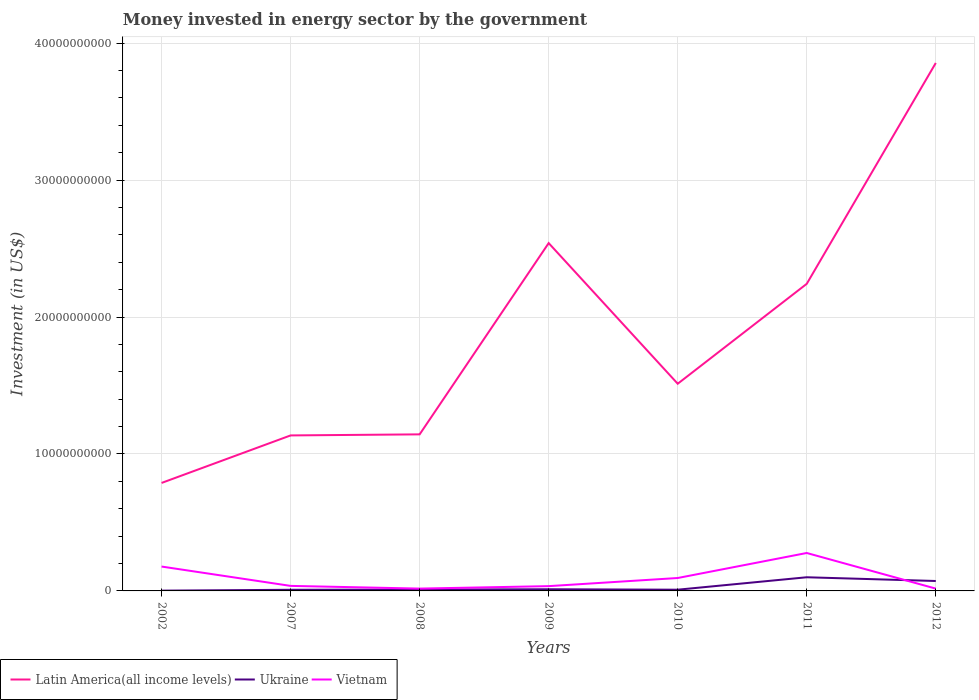How many different coloured lines are there?
Ensure brevity in your answer.  3. Is the number of lines equal to the number of legend labels?
Offer a very short reply. Yes. Across all years, what is the maximum money spent in energy sector in Latin America(all income levels)?
Your answer should be compact. 7.89e+09. In which year was the money spent in energy sector in Latin America(all income levels) maximum?
Your answer should be compact. 2002. What is the total money spent in energy sector in Vietnam in the graph?
Keep it short and to the point. -2.60e+09. What is the difference between the highest and the second highest money spent in energy sector in Ukraine?
Offer a terse response. 9.78e+08. What is the difference between the highest and the lowest money spent in energy sector in Latin America(all income levels)?
Keep it short and to the point. 3. Is the money spent in energy sector in Ukraine strictly greater than the money spent in energy sector in Vietnam over the years?
Make the answer very short. No. How many lines are there?
Provide a succinct answer. 3. Are the values on the major ticks of Y-axis written in scientific E-notation?
Ensure brevity in your answer.  No. Does the graph contain any zero values?
Provide a short and direct response. No. Where does the legend appear in the graph?
Your answer should be compact. Bottom left. How are the legend labels stacked?
Your response must be concise. Horizontal. What is the title of the graph?
Your response must be concise. Money invested in energy sector by the government. What is the label or title of the X-axis?
Provide a short and direct response. Years. What is the label or title of the Y-axis?
Your answer should be compact. Investment (in US$). What is the Investment (in US$) of Latin America(all income levels) in 2002?
Ensure brevity in your answer.  7.89e+09. What is the Investment (in US$) in Ukraine in 2002?
Provide a succinct answer. 2.00e+07. What is the Investment (in US$) of Vietnam in 2002?
Make the answer very short. 1.78e+09. What is the Investment (in US$) of Latin America(all income levels) in 2007?
Keep it short and to the point. 1.14e+1. What is the Investment (in US$) of Ukraine in 2007?
Make the answer very short. 8.34e+07. What is the Investment (in US$) of Vietnam in 2007?
Give a very brief answer. 3.67e+08. What is the Investment (in US$) of Latin America(all income levels) in 2008?
Your answer should be very brief. 1.14e+1. What is the Investment (in US$) of Ukraine in 2008?
Offer a very short reply. 1.00e+08. What is the Investment (in US$) in Vietnam in 2008?
Make the answer very short. 1.70e+08. What is the Investment (in US$) of Latin America(all income levels) in 2009?
Keep it short and to the point. 2.54e+1. What is the Investment (in US$) of Ukraine in 2009?
Provide a short and direct response. 1.21e+08. What is the Investment (in US$) of Vietnam in 2009?
Provide a succinct answer. 3.49e+08. What is the Investment (in US$) in Latin America(all income levels) in 2010?
Keep it short and to the point. 1.51e+1. What is the Investment (in US$) of Ukraine in 2010?
Offer a terse response. 8.89e+07. What is the Investment (in US$) of Vietnam in 2010?
Offer a very short reply. 9.43e+08. What is the Investment (in US$) of Latin America(all income levels) in 2011?
Offer a terse response. 2.24e+1. What is the Investment (in US$) of Ukraine in 2011?
Your response must be concise. 9.98e+08. What is the Investment (in US$) of Vietnam in 2011?
Your answer should be compact. 2.77e+09. What is the Investment (in US$) in Latin America(all income levels) in 2012?
Make the answer very short. 3.86e+1. What is the Investment (in US$) in Ukraine in 2012?
Give a very brief answer. 7.24e+08. What is the Investment (in US$) in Vietnam in 2012?
Make the answer very short. 1.69e+08. Across all years, what is the maximum Investment (in US$) of Latin America(all income levels)?
Make the answer very short. 3.86e+1. Across all years, what is the maximum Investment (in US$) in Ukraine?
Give a very brief answer. 9.98e+08. Across all years, what is the maximum Investment (in US$) of Vietnam?
Offer a terse response. 2.77e+09. Across all years, what is the minimum Investment (in US$) in Latin America(all income levels)?
Make the answer very short. 7.89e+09. Across all years, what is the minimum Investment (in US$) in Vietnam?
Your answer should be very brief. 1.69e+08. What is the total Investment (in US$) of Latin America(all income levels) in the graph?
Make the answer very short. 1.32e+11. What is the total Investment (in US$) in Ukraine in the graph?
Provide a short and direct response. 2.14e+09. What is the total Investment (in US$) of Vietnam in the graph?
Offer a terse response. 6.55e+09. What is the difference between the Investment (in US$) of Latin America(all income levels) in 2002 and that in 2007?
Offer a terse response. -3.47e+09. What is the difference between the Investment (in US$) in Ukraine in 2002 and that in 2007?
Provide a short and direct response. -6.34e+07. What is the difference between the Investment (in US$) of Vietnam in 2002 and that in 2007?
Offer a terse response. 1.41e+09. What is the difference between the Investment (in US$) of Latin America(all income levels) in 2002 and that in 2008?
Offer a terse response. -3.55e+09. What is the difference between the Investment (in US$) of Ukraine in 2002 and that in 2008?
Give a very brief answer. -8.01e+07. What is the difference between the Investment (in US$) in Vietnam in 2002 and that in 2008?
Your answer should be very brief. 1.61e+09. What is the difference between the Investment (in US$) of Latin America(all income levels) in 2002 and that in 2009?
Offer a very short reply. -1.75e+1. What is the difference between the Investment (in US$) in Ukraine in 2002 and that in 2009?
Provide a short and direct response. -1.01e+08. What is the difference between the Investment (in US$) in Vietnam in 2002 and that in 2009?
Ensure brevity in your answer.  1.43e+09. What is the difference between the Investment (in US$) of Latin America(all income levels) in 2002 and that in 2010?
Provide a short and direct response. -7.24e+09. What is the difference between the Investment (in US$) in Ukraine in 2002 and that in 2010?
Provide a succinct answer. -6.89e+07. What is the difference between the Investment (in US$) in Vietnam in 2002 and that in 2010?
Your answer should be very brief. 8.37e+08. What is the difference between the Investment (in US$) in Latin America(all income levels) in 2002 and that in 2011?
Provide a short and direct response. -1.45e+1. What is the difference between the Investment (in US$) of Ukraine in 2002 and that in 2011?
Keep it short and to the point. -9.78e+08. What is the difference between the Investment (in US$) in Vietnam in 2002 and that in 2011?
Provide a succinct answer. -9.90e+08. What is the difference between the Investment (in US$) in Latin America(all income levels) in 2002 and that in 2012?
Your response must be concise. -3.07e+1. What is the difference between the Investment (in US$) of Ukraine in 2002 and that in 2012?
Your answer should be compact. -7.04e+08. What is the difference between the Investment (in US$) of Vietnam in 2002 and that in 2012?
Offer a terse response. 1.61e+09. What is the difference between the Investment (in US$) in Latin America(all income levels) in 2007 and that in 2008?
Your answer should be compact. -7.74e+07. What is the difference between the Investment (in US$) of Ukraine in 2007 and that in 2008?
Provide a succinct answer. -1.67e+07. What is the difference between the Investment (in US$) in Vietnam in 2007 and that in 2008?
Your answer should be compact. 1.97e+08. What is the difference between the Investment (in US$) of Latin America(all income levels) in 2007 and that in 2009?
Your answer should be very brief. -1.40e+1. What is the difference between the Investment (in US$) of Ukraine in 2007 and that in 2009?
Make the answer very short. -3.73e+07. What is the difference between the Investment (in US$) in Vietnam in 2007 and that in 2009?
Offer a very short reply. 1.81e+07. What is the difference between the Investment (in US$) of Latin America(all income levels) in 2007 and that in 2010?
Give a very brief answer. -3.77e+09. What is the difference between the Investment (in US$) of Ukraine in 2007 and that in 2010?
Provide a succinct answer. -5.51e+06. What is the difference between the Investment (in US$) in Vietnam in 2007 and that in 2010?
Offer a very short reply. -5.76e+08. What is the difference between the Investment (in US$) in Latin America(all income levels) in 2007 and that in 2011?
Provide a short and direct response. -1.11e+1. What is the difference between the Investment (in US$) in Ukraine in 2007 and that in 2011?
Offer a terse response. -9.14e+08. What is the difference between the Investment (in US$) of Vietnam in 2007 and that in 2011?
Your response must be concise. -2.40e+09. What is the difference between the Investment (in US$) in Latin America(all income levels) in 2007 and that in 2012?
Provide a succinct answer. -2.72e+1. What is the difference between the Investment (in US$) in Ukraine in 2007 and that in 2012?
Provide a succinct answer. -6.41e+08. What is the difference between the Investment (in US$) of Vietnam in 2007 and that in 2012?
Keep it short and to the point. 1.99e+08. What is the difference between the Investment (in US$) in Latin America(all income levels) in 2008 and that in 2009?
Offer a very short reply. -1.40e+1. What is the difference between the Investment (in US$) of Ukraine in 2008 and that in 2009?
Ensure brevity in your answer.  -2.06e+07. What is the difference between the Investment (in US$) of Vietnam in 2008 and that in 2009?
Keep it short and to the point. -1.79e+08. What is the difference between the Investment (in US$) of Latin America(all income levels) in 2008 and that in 2010?
Provide a succinct answer. -3.70e+09. What is the difference between the Investment (in US$) of Ukraine in 2008 and that in 2010?
Ensure brevity in your answer.  1.12e+07. What is the difference between the Investment (in US$) of Vietnam in 2008 and that in 2010?
Make the answer very short. -7.73e+08. What is the difference between the Investment (in US$) in Latin America(all income levels) in 2008 and that in 2011?
Provide a short and direct response. -1.10e+1. What is the difference between the Investment (in US$) in Ukraine in 2008 and that in 2011?
Your answer should be compact. -8.98e+08. What is the difference between the Investment (in US$) of Vietnam in 2008 and that in 2011?
Your answer should be compact. -2.60e+09. What is the difference between the Investment (in US$) of Latin America(all income levels) in 2008 and that in 2012?
Your response must be concise. -2.71e+1. What is the difference between the Investment (in US$) in Ukraine in 2008 and that in 2012?
Your answer should be very brief. -6.24e+08. What is the difference between the Investment (in US$) in Vietnam in 2008 and that in 2012?
Give a very brief answer. 1.50e+06. What is the difference between the Investment (in US$) in Latin America(all income levels) in 2009 and that in 2010?
Give a very brief answer. 1.03e+1. What is the difference between the Investment (in US$) in Ukraine in 2009 and that in 2010?
Offer a very short reply. 3.18e+07. What is the difference between the Investment (in US$) of Vietnam in 2009 and that in 2010?
Your response must be concise. -5.94e+08. What is the difference between the Investment (in US$) of Latin America(all income levels) in 2009 and that in 2011?
Provide a short and direct response. 2.97e+09. What is the difference between the Investment (in US$) of Ukraine in 2009 and that in 2011?
Your answer should be very brief. -8.77e+08. What is the difference between the Investment (in US$) in Vietnam in 2009 and that in 2011?
Offer a very short reply. -2.42e+09. What is the difference between the Investment (in US$) of Latin America(all income levels) in 2009 and that in 2012?
Provide a short and direct response. -1.32e+1. What is the difference between the Investment (in US$) of Ukraine in 2009 and that in 2012?
Provide a succinct answer. -6.04e+08. What is the difference between the Investment (in US$) of Vietnam in 2009 and that in 2012?
Your response must be concise. 1.80e+08. What is the difference between the Investment (in US$) in Latin America(all income levels) in 2010 and that in 2011?
Provide a short and direct response. -7.30e+09. What is the difference between the Investment (in US$) of Ukraine in 2010 and that in 2011?
Offer a very short reply. -9.09e+08. What is the difference between the Investment (in US$) of Vietnam in 2010 and that in 2011?
Your answer should be very brief. -1.83e+09. What is the difference between the Investment (in US$) in Latin America(all income levels) in 2010 and that in 2012?
Offer a terse response. -2.34e+1. What is the difference between the Investment (in US$) in Ukraine in 2010 and that in 2012?
Offer a very short reply. -6.36e+08. What is the difference between the Investment (in US$) in Vietnam in 2010 and that in 2012?
Offer a terse response. 7.74e+08. What is the difference between the Investment (in US$) in Latin America(all income levels) in 2011 and that in 2012?
Ensure brevity in your answer.  -1.61e+1. What is the difference between the Investment (in US$) in Ukraine in 2011 and that in 2012?
Provide a succinct answer. 2.73e+08. What is the difference between the Investment (in US$) in Vietnam in 2011 and that in 2012?
Offer a very short reply. 2.60e+09. What is the difference between the Investment (in US$) of Latin America(all income levels) in 2002 and the Investment (in US$) of Ukraine in 2007?
Keep it short and to the point. 7.80e+09. What is the difference between the Investment (in US$) in Latin America(all income levels) in 2002 and the Investment (in US$) in Vietnam in 2007?
Your answer should be compact. 7.52e+09. What is the difference between the Investment (in US$) in Ukraine in 2002 and the Investment (in US$) in Vietnam in 2007?
Provide a short and direct response. -3.47e+08. What is the difference between the Investment (in US$) in Latin America(all income levels) in 2002 and the Investment (in US$) in Ukraine in 2008?
Your answer should be compact. 7.79e+09. What is the difference between the Investment (in US$) of Latin America(all income levels) in 2002 and the Investment (in US$) of Vietnam in 2008?
Provide a succinct answer. 7.72e+09. What is the difference between the Investment (in US$) in Ukraine in 2002 and the Investment (in US$) in Vietnam in 2008?
Offer a very short reply. -1.50e+08. What is the difference between the Investment (in US$) of Latin America(all income levels) in 2002 and the Investment (in US$) of Ukraine in 2009?
Make the answer very short. 7.77e+09. What is the difference between the Investment (in US$) of Latin America(all income levels) in 2002 and the Investment (in US$) of Vietnam in 2009?
Give a very brief answer. 7.54e+09. What is the difference between the Investment (in US$) of Ukraine in 2002 and the Investment (in US$) of Vietnam in 2009?
Ensure brevity in your answer.  -3.29e+08. What is the difference between the Investment (in US$) of Latin America(all income levels) in 2002 and the Investment (in US$) of Ukraine in 2010?
Provide a short and direct response. 7.80e+09. What is the difference between the Investment (in US$) in Latin America(all income levels) in 2002 and the Investment (in US$) in Vietnam in 2010?
Your answer should be compact. 6.94e+09. What is the difference between the Investment (in US$) in Ukraine in 2002 and the Investment (in US$) in Vietnam in 2010?
Offer a very short reply. -9.23e+08. What is the difference between the Investment (in US$) in Latin America(all income levels) in 2002 and the Investment (in US$) in Ukraine in 2011?
Offer a very short reply. 6.89e+09. What is the difference between the Investment (in US$) of Latin America(all income levels) in 2002 and the Investment (in US$) of Vietnam in 2011?
Provide a succinct answer. 5.12e+09. What is the difference between the Investment (in US$) of Ukraine in 2002 and the Investment (in US$) of Vietnam in 2011?
Keep it short and to the point. -2.75e+09. What is the difference between the Investment (in US$) in Latin America(all income levels) in 2002 and the Investment (in US$) in Ukraine in 2012?
Offer a terse response. 7.16e+09. What is the difference between the Investment (in US$) of Latin America(all income levels) in 2002 and the Investment (in US$) of Vietnam in 2012?
Ensure brevity in your answer.  7.72e+09. What is the difference between the Investment (in US$) of Ukraine in 2002 and the Investment (in US$) of Vietnam in 2012?
Provide a succinct answer. -1.49e+08. What is the difference between the Investment (in US$) in Latin America(all income levels) in 2007 and the Investment (in US$) in Ukraine in 2008?
Provide a succinct answer. 1.13e+1. What is the difference between the Investment (in US$) of Latin America(all income levels) in 2007 and the Investment (in US$) of Vietnam in 2008?
Make the answer very short. 1.12e+1. What is the difference between the Investment (in US$) of Ukraine in 2007 and the Investment (in US$) of Vietnam in 2008?
Ensure brevity in your answer.  -8.69e+07. What is the difference between the Investment (in US$) in Latin America(all income levels) in 2007 and the Investment (in US$) in Ukraine in 2009?
Provide a succinct answer. 1.12e+1. What is the difference between the Investment (in US$) in Latin America(all income levels) in 2007 and the Investment (in US$) in Vietnam in 2009?
Your answer should be compact. 1.10e+1. What is the difference between the Investment (in US$) in Ukraine in 2007 and the Investment (in US$) in Vietnam in 2009?
Give a very brief answer. -2.66e+08. What is the difference between the Investment (in US$) of Latin America(all income levels) in 2007 and the Investment (in US$) of Ukraine in 2010?
Provide a short and direct response. 1.13e+1. What is the difference between the Investment (in US$) in Latin America(all income levels) in 2007 and the Investment (in US$) in Vietnam in 2010?
Ensure brevity in your answer.  1.04e+1. What is the difference between the Investment (in US$) in Ukraine in 2007 and the Investment (in US$) in Vietnam in 2010?
Give a very brief answer. -8.60e+08. What is the difference between the Investment (in US$) of Latin America(all income levels) in 2007 and the Investment (in US$) of Ukraine in 2011?
Ensure brevity in your answer.  1.04e+1. What is the difference between the Investment (in US$) of Latin America(all income levels) in 2007 and the Investment (in US$) of Vietnam in 2011?
Ensure brevity in your answer.  8.59e+09. What is the difference between the Investment (in US$) in Ukraine in 2007 and the Investment (in US$) in Vietnam in 2011?
Provide a succinct answer. -2.69e+09. What is the difference between the Investment (in US$) in Latin America(all income levels) in 2007 and the Investment (in US$) in Ukraine in 2012?
Provide a short and direct response. 1.06e+1. What is the difference between the Investment (in US$) in Latin America(all income levels) in 2007 and the Investment (in US$) in Vietnam in 2012?
Keep it short and to the point. 1.12e+1. What is the difference between the Investment (in US$) in Ukraine in 2007 and the Investment (in US$) in Vietnam in 2012?
Ensure brevity in your answer.  -8.54e+07. What is the difference between the Investment (in US$) in Latin America(all income levels) in 2008 and the Investment (in US$) in Ukraine in 2009?
Offer a terse response. 1.13e+1. What is the difference between the Investment (in US$) in Latin America(all income levels) in 2008 and the Investment (in US$) in Vietnam in 2009?
Ensure brevity in your answer.  1.11e+1. What is the difference between the Investment (in US$) of Ukraine in 2008 and the Investment (in US$) of Vietnam in 2009?
Your answer should be compact. -2.49e+08. What is the difference between the Investment (in US$) in Latin America(all income levels) in 2008 and the Investment (in US$) in Ukraine in 2010?
Ensure brevity in your answer.  1.13e+1. What is the difference between the Investment (in US$) of Latin America(all income levels) in 2008 and the Investment (in US$) of Vietnam in 2010?
Your response must be concise. 1.05e+1. What is the difference between the Investment (in US$) of Ukraine in 2008 and the Investment (in US$) of Vietnam in 2010?
Provide a succinct answer. -8.43e+08. What is the difference between the Investment (in US$) of Latin America(all income levels) in 2008 and the Investment (in US$) of Ukraine in 2011?
Ensure brevity in your answer.  1.04e+1. What is the difference between the Investment (in US$) in Latin America(all income levels) in 2008 and the Investment (in US$) in Vietnam in 2011?
Offer a very short reply. 8.66e+09. What is the difference between the Investment (in US$) in Ukraine in 2008 and the Investment (in US$) in Vietnam in 2011?
Provide a short and direct response. -2.67e+09. What is the difference between the Investment (in US$) in Latin America(all income levels) in 2008 and the Investment (in US$) in Ukraine in 2012?
Offer a terse response. 1.07e+1. What is the difference between the Investment (in US$) in Latin America(all income levels) in 2008 and the Investment (in US$) in Vietnam in 2012?
Give a very brief answer. 1.13e+1. What is the difference between the Investment (in US$) of Ukraine in 2008 and the Investment (in US$) of Vietnam in 2012?
Ensure brevity in your answer.  -6.87e+07. What is the difference between the Investment (in US$) of Latin America(all income levels) in 2009 and the Investment (in US$) of Ukraine in 2010?
Keep it short and to the point. 2.53e+1. What is the difference between the Investment (in US$) in Latin America(all income levels) in 2009 and the Investment (in US$) in Vietnam in 2010?
Make the answer very short. 2.45e+1. What is the difference between the Investment (in US$) in Ukraine in 2009 and the Investment (in US$) in Vietnam in 2010?
Give a very brief answer. -8.22e+08. What is the difference between the Investment (in US$) of Latin America(all income levels) in 2009 and the Investment (in US$) of Ukraine in 2011?
Offer a very short reply. 2.44e+1. What is the difference between the Investment (in US$) of Latin America(all income levels) in 2009 and the Investment (in US$) of Vietnam in 2011?
Your answer should be very brief. 2.26e+1. What is the difference between the Investment (in US$) of Ukraine in 2009 and the Investment (in US$) of Vietnam in 2011?
Your response must be concise. -2.65e+09. What is the difference between the Investment (in US$) of Latin America(all income levels) in 2009 and the Investment (in US$) of Ukraine in 2012?
Offer a terse response. 2.47e+1. What is the difference between the Investment (in US$) of Latin America(all income levels) in 2009 and the Investment (in US$) of Vietnam in 2012?
Provide a short and direct response. 2.52e+1. What is the difference between the Investment (in US$) of Ukraine in 2009 and the Investment (in US$) of Vietnam in 2012?
Provide a short and direct response. -4.81e+07. What is the difference between the Investment (in US$) in Latin America(all income levels) in 2010 and the Investment (in US$) in Ukraine in 2011?
Ensure brevity in your answer.  1.41e+1. What is the difference between the Investment (in US$) in Latin America(all income levels) in 2010 and the Investment (in US$) in Vietnam in 2011?
Ensure brevity in your answer.  1.24e+1. What is the difference between the Investment (in US$) in Ukraine in 2010 and the Investment (in US$) in Vietnam in 2011?
Your response must be concise. -2.68e+09. What is the difference between the Investment (in US$) in Latin America(all income levels) in 2010 and the Investment (in US$) in Ukraine in 2012?
Give a very brief answer. 1.44e+1. What is the difference between the Investment (in US$) in Latin America(all income levels) in 2010 and the Investment (in US$) in Vietnam in 2012?
Make the answer very short. 1.50e+1. What is the difference between the Investment (in US$) in Ukraine in 2010 and the Investment (in US$) in Vietnam in 2012?
Your answer should be compact. -7.99e+07. What is the difference between the Investment (in US$) of Latin America(all income levels) in 2011 and the Investment (in US$) of Ukraine in 2012?
Offer a very short reply. 2.17e+1. What is the difference between the Investment (in US$) in Latin America(all income levels) in 2011 and the Investment (in US$) in Vietnam in 2012?
Your answer should be very brief. 2.23e+1. What is the difference between the Investment (in US$) in Ukraine in 2011 and the Investment (in US$) in Vietnam in 2012?
Keep it short and to the point. 8.29e+08. What is the average Investment (in US$) in Latin America(all income levels) per year?
Your answer should be compact. 1.89e+1. What is the average Investment (in US$) of Ukraine per year?
Ensure brevity in your answer.  3.05e+08. What is the average Investment (in US$) in Vietnam per year?
Give a very brief answer. 9.36e+08. In the year 2002, what is the difference between the Investment (in US$) in Latin America(all income levels) and Investment (in US$) in Ukraine?
Your answer should be compact. 7.87e+09. In the year 2002, what is the difference between the Investment (in US$) of Latin America(all income levels) and Investment (in US$) of Vietnam?
Give a very brief answer. 6.11e+09. In the year 2002, what is the difference between the Investment (in US$) in Ukraine and Investment (in US$) in Vietnam?
Your response must be concise. -1.76e+09. In the year 2007, what is the difference between the Investment (in US$) of Latin America(all income levels) and Investment (in US$) of Ukraine?
Provide a short and direct response. 1.13e+1. In the year 2007, what is the difference between the Investment (in US$) in Latin America(all income levels) and Investment (in US$) in Vietnam?
Offer a very short reply. 1.10e+1. In the year 2007, what is the difference between the Investment (in US$) of Ukraine and Investment (in US$) of Vietnam?
Ensure brevity in your answer.  -2.84e+08. In the year 2008, what is the difference between the Investment (in US$) in Latin America(all income levels) and Investment (in US$) in Ukraine?
Your answer should be very brief. 1.13e+1. In the year 2008, what is the difference between the Investment (in US$) of Latin America(all income levels) and Investment (in US$) of Vietnam?
Give a very brief answer. 1.13e+1. In the year 2008, what is the difference between the Investment (in US$) in Ukraine and Investment (in US$) in Vietnam?
Your answer should be very brief. -7.02e+07. In the year 2009, what is the difference between the Investment (in US$) in Latin America(all income levels) and Investment (in US$) in Ukraine?
Offer a terse response. 2.53e+1. In the year 2009, what is the difference between the Investment (in US$) of Latin America(all income levels) and Investment (in US$) of Vietnam?
Provide a succinct answer. 2.51e+1. In the year 2009, what is the difference between the Investment (in US$) in Ukraine and Investment (in US$) in Vietnam?
Your answer should be compact. -2.29e+08. In the year 2010, what is the difference between the Investment (in US$) in Latin America(all income levels) and Investment (in US$) in Ukraine?
Provide a succinct answer. 1.50e+1. In the year 2010, what is the difference between the Investment (in US$) in Latin America(all income levels) and Investment (in US$) in Vietnam?
Offer a terse response. 1.42e+1. In the year 2010, what is the difference between the Investment (in US$) of Ukraine and Investment (in US$) of Vietnam?
Provide a short and direct response. -8.54e+08. In the year 2011, what is the difference between the Investment (in US$) of Latin America(all income levels) and Investment (in US$) of Ukraine?
Offer a terse response. 2.14e+1. In the year 2011, what is the difference between the Investment (in US$) of Latin America(all income levels) and Investment (in US$) of Vietnam?
Provide a short and direct response. 1.97e+1. In the year 2011, what is the difference between the Investment (in US$) in Ukraine and Investment (in US$) in Vietnam?
Your answer should be compact. -1.77e+09. In the year 2012, what is the difference between the Investment (in US$) of Latin America(all income levels) and Investment (in US$) of Ukraine?
Your answer should be compact. 3.78e+1. In the year 2012, what is the difference between the Investment (in US$) in Latin America(all income levels) and Investment (in US$) in Vietnam?
Ensure brevity in your answer.  3.84e+1. In the year 2012, what is the difference between the Investment (in US$) of Ukraine and Investment (in US$) of Vietnam?
Offer a terse response. 5.56e+08. What is the ratio of the Investment (in US$) of Latin America(all income levels) in 2002 to that in 2007?
Your response must be concise. 0.69. What is the ratio of the Investment (in US$) of Ukraine in 2002 to that in 2007?
Provide a succinct answer. 0.24. What is the ratio of the Investment (in US$) of Vietnam in 2002 to that in 2007?
Provide a succinct answer. 4.85. What is the ratio of the Investment (in US$) in Latin America(all income levels) in 2002 to that in 2008?
Keep it short and to the point. 0.69. What is the ratio of the Investment (in US$) of Ukraine in 2002 to that in 2008?
Provide a succinct answer. 0.2. What is the ratio of the Investment (in US$) in Vietnam in 2002 to that in 2008?
Your response must be concise. 10.45. What is the ratio of the Investment (in US$) in Latin America(all income levels) in 2002 to that in 2009?
Provide a short and direct response. 0.31. What is the ratio of the Investment (in US$) of Ukraine in 2002 to that in 2009?
Your response must be concise. 0.17. What is the ratio of the Investment (in US$) in Vietnam in 2002 to that in 2009?
Offer a terse response. 5.1. What is the ratio of the Investment (in US$) in Latin America(all income levels) in 2002 to that in 2010?
Your answer should be very brief. 0.52. What is the ratio of the Investment (in US$) of Ukraine in 2002 to that in 2010?
Your response must be concise. 0.22. What is the ratio of the Investment (in US$) of Vietnam in 2002 to that in 2010?
Offer a terse response. 1.89. What is the ratio of the Investment (in US$) in Latin America(all income levels) in 2002 to that in 2011?
Provide a short and direct response. 0.35. What is the ratio of the Investment (in US$) in Vietnam in 2002 to that in 2011?
Give a very brief answer. 0.64. What is the ratio of the Investment (in US$) in Latin America(all income levels) in 2002 to that in 2012?
Keep it short and to the point. 0.2. What is the ratio of the Investment (in US$) in Ukraine in 2002 to that in 2012?
Provide a short and direct response. 0.03. What is the ratio of the Investment (in US$) of Vietnam in 2002 to that in 2012?
Provide a succinct answer. 10.54. What is the ratio of the Investment (in US$) of Ukraine in 2007 to that in 2008?
Make the answer very short. 0.83. What is the ratio of the Investment (in US$) of Vietnam in 2007 to that in 2008?
Provide a succinct answer. 2.16. What is the ratio of the Investment (in US$) in Latin America(all income levels) in 2007 to that in 2009?
Provide a short and direct response. 0.45. What is the ratio of the Investment (in US$) in Ukraine in 2007 to that in 2009?
Provide a short and direct response. 0.69. What is the ratio of the Investment (in US$) in Vietnam in 2007 to that in 2009?
Make the answer very short. 1.05. What is the ratio of the Investment (in US$) in Latin America(all income levels) in 2007 to that in 2010?
Offer a very short reply. 0.75. What is the ratio of the Investment (in US$) of Ukraine in 2007 to that in 2010?
Keep it short and to the point. 0.94. What is the ratio of the Investment (in US$) of Vietnam in 2007 to that in 2010?
Offer a terse response. 0.39. What is the ratio of the Investment (in US$) of Latin America(all income levels) in 2007 to that in 2011?
Provide a short and direct response. 0.51. What is the ratio of the Investment (in US$) in Ukraine in 2007 to that in 2011?
Your answer should be very brief. 0.08. What is the ratio of the Investment (in US$) of Vietnam in 2007 to that in 2011?
Ensure brevity in your answer.  0.13. What is the ratio of the Investment (in US$) in Latin America(all income levels) in 2007 to that in 2012?
Offer a terse response. 0.29. What is the ratio of the Investment (in US$) in Ukraine in 2007 to that in 2012?
Provide a succinct answer. 0.12. What is the ratio of the Investment (in US$) in Vietnam in 2007 to that in 2012?
Your answer should be compact. 2.18. What is the ratio of the Investment (in US$) of Latin America(all income levels) in 2008 to that in 2009?
Provide a short and direct response. 0.45. What is the ratio of the Investment (in US$) in Ukraine in 2008 to that in 2009?
Make the answer very short. 0.83. What is the ratio of the Investment (in US$) of Vietnam in 2008 to that in 2009?
Provide a succinct answer. 0.49. What is the ratio of the Investment (in US$) of Latin America(all income levels) in 2008 to that in 2010?
Provide a succinct answer. 0.76. What is the ratio of the Investment (in US$) in Ukraine in 2008 to that in 2010?
Offer a very short reply. 1.13. What is the ratio of the Investment (in US$) of Vietnam in 2008 to that in 2010?
Keep it short and to the point. 0.18. What is the ratio of the Investment (in US$) in Latin America(all income levels) in 2008 to that in 2011?
Keep it short and to the point. 0.51. What is the ratio of the Investment (in US$) of Ukraine in 2008 to that in 2011?
Give a very brief answer. 0.1. What is the ratio of the Investment (in US$) of Vietnam in 2008 to that in 2011?
Make the answer very short. 0.06. What is the ratio of the Investment (in US$) of Latin America(all income levels) in 2008 to that in 2012?
Provide a short and direct response. 0.3. What is the ratio of the Investment (in US$) in Ukraine in 2008 to that in 2012?
Make the answer very short. 0.14. What is the ratio of the Investment (in US$) in Vietnam in 2008 to that in 2012?
Your answer should be compact. 1.01. What is the ratio of the Investment (in US$) of Latin America(all income levels) in 2009 to that in 2010?
Your answer should be very brief. 1.68. What is the ratio of the Investment (in US$) of Ukraine in 2009 to that in 2010?
Make the answer very short. 1.36. What is the ratio of the Investment (in US$) of Vietnam in 2009 to that in 2010?
Your response must be concise. 0.37. What is the ratio of the Investment (in US$) in Latin America(all income levels) in 2009 to that in 2011?
Give a very brief answer. 1.13. What is the ratio of the Investment (in US$) in Ukraine in 2009 to that in 2011?
Provide a succinct answer. 0.12. What is the ratio of the Investment (in US$) in Vietnam in 2009 to that in 2011?
Make the answer very short. 0.13. What is the ratio of the Investment (in US$) in Latin America(all income levels) in 2009 to that in 2012?
Your answer should be compact. 0.66. What is the ratio of the Investment (in US$) in Ukraine in 2009 to that in 2012?
Your answer should be compact. 0.17. What is the ratio of the Investment (in US$) of Vietnam in 2009 to that in 2012?
Offer a very short reply. 2.07. What is the ratio of the Investment (in US$) of Latin America(all income levels) in 2010 to that in 2011?
Your answer should be compact. 0.67. What is the ratio of the Investment (in US$) of Ukraine in 2010 to that in 2011?
Offer a terse response. 0.09. What is the ratio of the Investment (in US$) of Vietnam in 2010 to that in 2011?
Your answer should be compact. 0.34. What is the ratio of the Investment (in US$) in Latin America(all income levels) in 2010 to that in 2012?
Ensure brevity in your answer.  0.39. What is the ratio of the Investment (in US$) of Ukraine in 2010 to that in 2012?
Offer a very short reply. 0.12. What is the ratio of the Investment (in US$) of Vietnam in 2010 to that in 2012?
Keep it short and to the point. 5.59. What is the ratio of the Investment (in US$) of Latin America(all income levels) in 2011 to that in 2012?
Offer a very short reply. 0.58. What is the ratio of the Investment (in US$) in Ukraine in 2011 to that in 2012?
Provide a succinct answer. 1.38. What is the ratio of the Investment (in US$) in Vietnam in 2011 to that in 2012?
Ensure brevity in your answer.  16.41. What is the difference between the highest and the second highest Investment (in US$) of Latin America(all income levels)?
Provide a short and direct response. 1.32e+1. What is the difference between the highest and the second highest Investment (in US$) of Ukraine?
Offer a terse response. 2.73e+08. What is the difference between the highest and the second highest Investment (in US$) in Vietnam?
Ensure brevity in your answer.  9.90e+08. What is the difference between the highest and the lowest Investment (in US$) of Latin America(all income levels)?
Your response must be concise. 3.07e+1. What is the difference between the highest and the lowest Investment (in US$) in Ukraine?
Your response must be concise. 9.78e+08. What is the difference between the highest and the lowest Investment (in US$) in Vietnam?
Offer a terse response. 2.60e+09. 